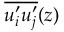<formula> <loc_0><loc_0><loc_500><loc_500>\overline { { u _ { i } ^ { \prime } u _ { j } ^ { \prime } } } ( z )</formula> 